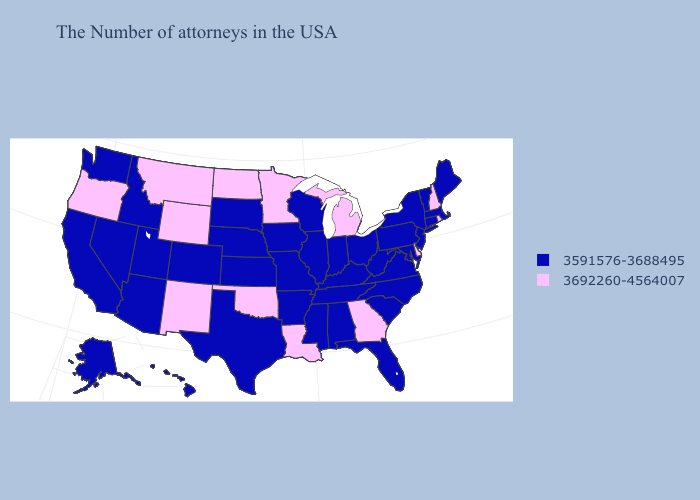Among the states that border North Dakota , which have the highest value?
Concise answer only. Minnesota, Montana. Is the legend a continuous bar?
Short answer required. No. Does Wyoming have the lowest value in the USA?
Give a very brief answer. No. What is the lowest value in states that border Utah?
Short answer required. 3591576-3688495. Among the states that border Maryland , which have the lowest value?
Give a very brief answer. Pennsylvania, Virginia, West Virginia. What is the value of West Virginia?
Write a very short answer. 3591576-3688495. Which states have the lowest value in the MidWest?
Answer briefly. Ohio, Indiana, Wisconsin, Illinois, Missouri, Iowa, Kansas, Nebraska, South Dakota. Does the map have missing data?
Write a very short answer. No. Which states have the highest value in the USA?
Be succinct. Rhode Island, New Hampshire, Delaware, Georgia, Michigan, Louisiana, Minnesota, Oklahoma, North Dakota, Wyoming, New Mexico, Montana, Oregon. Name the states that have a value in the range 3692260-4564007?
Give a very brief answer. Rhode Island, New Hampshire, Delaware, Georgia, Michigan, Louisiana, Minnesota, Oklahoma, North Dakota, Wyoming, New Mexico, Montana, Oregon. Does Mississippi have the same value as Connecticut?
Give a very brief answer. Yes. How many symbols are there in the legend?
Concise answer only. 2. Does Wyoming have the same value as Arkansas?
Concise answer only. No. Which states hav the highest value in the West?
Quick response, please. Wyoming, New Mexico, Montana, Oregon. 